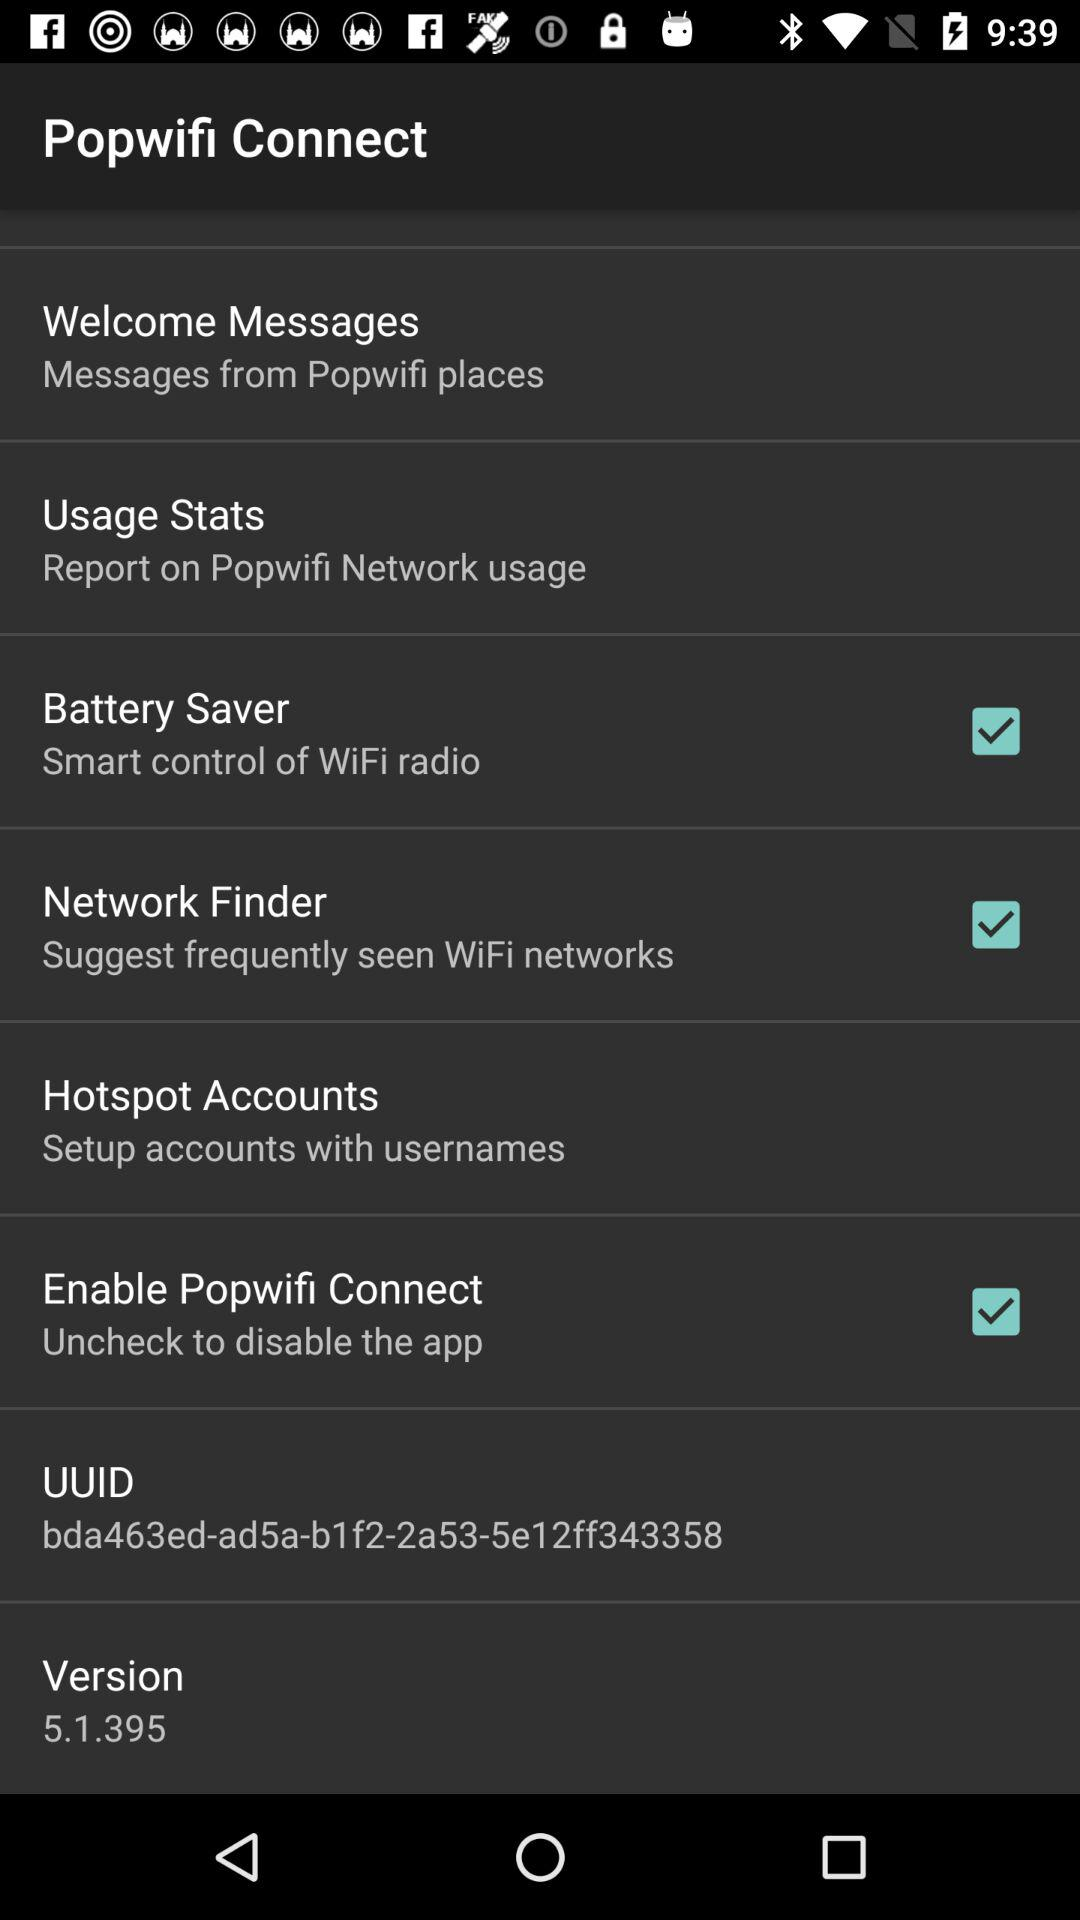What is the status of "Battery Saver"? The status is "on". 